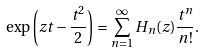<formula> <loc_0><loc_0><loc_500><loc_500>\exp \left ( z t - \frac { t ^ { 2 } } { 2 } \right ) = \sum _ { n = 1 } ^ { \infty } H _ { n } ( z ) \frac { t ^ { n } } { n ! } .</formula> 